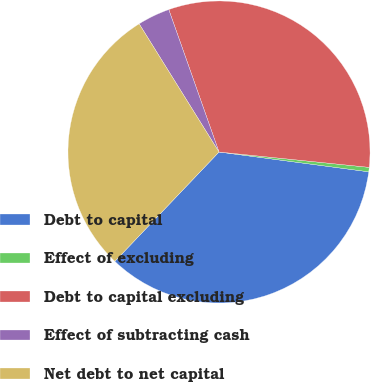Convert chart to OTSL. <chart><loc_0><loc_0><loc_500><loc_500><pie_chart><fcel>Debt to capital<fcel>Effect of excluding<fcel>Debt to capital excluding<fcel>Effect of subtracting cash<fcel>Net debt to net capital<nl><fcel>35.02%<fcel>0.47%<fcel>32.02%<fcel>3.47%<fcel>29.02%<nl></chart> 